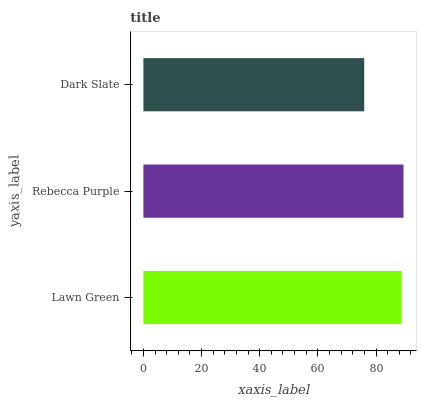Is Dark Slate the minimum?
Answer yes or no. Yes. Is Rebecca Purple the maximum?
Answer yes or no. Yes. Is Rebecca Purple the minimum?
Answer yes or no. No. Is Dark Slate the maximum?
Answer yes or no. No. Is Rebecca Purple greater than Dark Slate?
Answer yes or no. Yes. Is Dark Slate less than Rebecca Purple?
Answer yes or no. Yes. Is Dark Slate greater than Rebecca Purple?
Answer yes or no. No. Is Rebecca Purple less than Dark Slate?
Answer yes or no. No. Is Lawn Green the high median?
Answer yes or no. Yes. Is Lawn Green the low median?
Answer yes or no. Yes. Is Rebecca Purple the high median?
Answer yes or no. No. Is Rebecca Purple the low median?
Answer yes or no. No. 